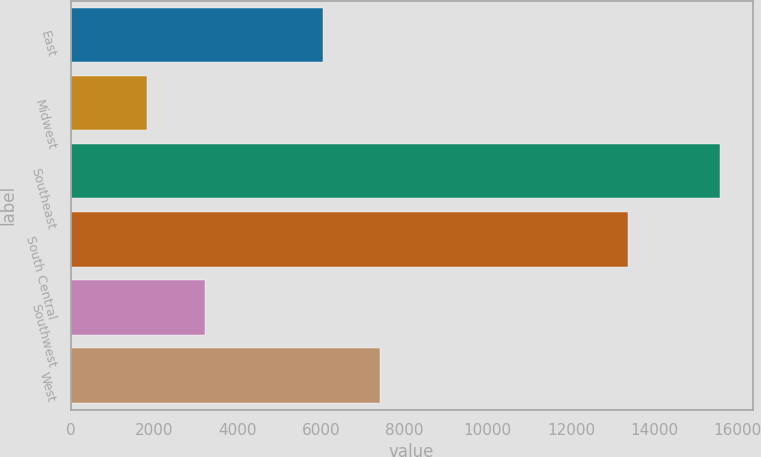<chart> <loc_0><loc_0><loc_500><loc_500><bar_chart><fcel>East<fcel>Midwest<fcel>Southeast<fcel>South Central<fcel>Southwest<fcel>West<nl><fcel>6039<fcel>1841<fcel>15575<fcel>13374<fcel>3214.4<fcel>7412.4<nl></chart> 